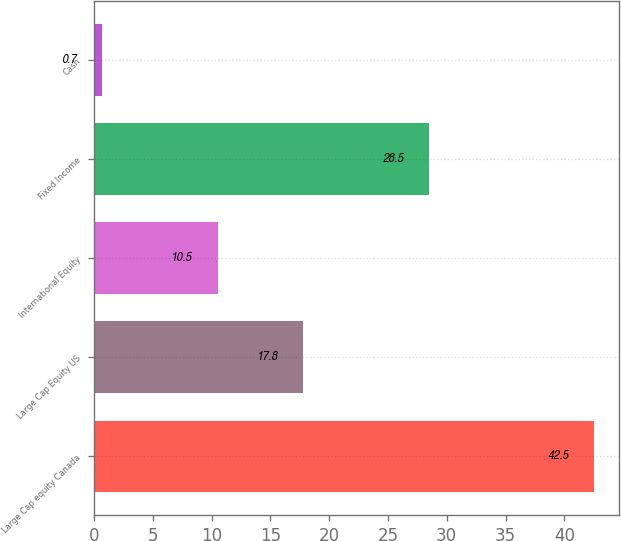<chart> <loc_0><loc_0><loc_500><loc_500><bar_chart><fcel>Large Cap equity Canada<fcel>Large Cap Equity US<fcel>International Equity<fcel>Fixed Income<fcel>Cash<nl><fcel>42.5<fcel>17.8<fcel>10.5<fcel>28.5<fcel>0.7<nl></chart> 